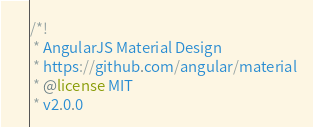<code> <loc_0><loc_0><loc_500><loc_500><_CSS_>/*!
 * AngularJS Material Design
 * https://github.com/angular/material
 * @license MIT
 * v2.0.0</code> 